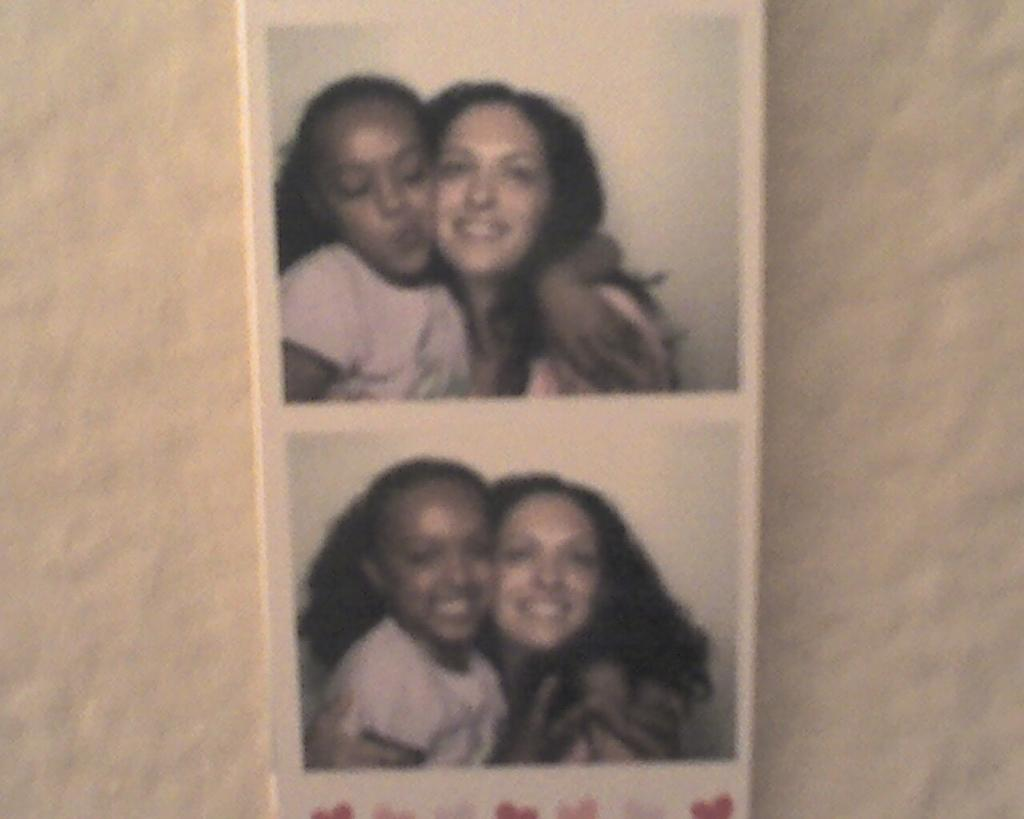What can be seen on the wall in the image? There are similar pictures on the wall. What subjects are depicted in the pictures? There is a woman and a girl in both pictures. How many goldfish are swimming in the picture? There are no goldfish present in the image; the pictures feature a woman and a girl. What type of coil is used to create the images? The provided facts do not mention any coils or the method used to create the images. 